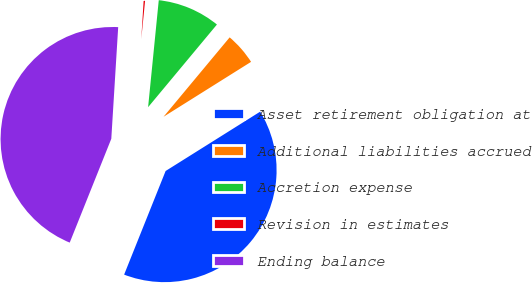Convert chart. <chart><loc_0><loc_0><loc_500><loc_500><pie_chart><fcel>Asset retirement obligation at<fcel>Additional liabilities accrued<fcel>Accretion expense<fcel>Revision in estimates<fcel>Ending balance<nl><fcel>39.98%<fcel>5.03%<fcel>9.47%<fcel>0.6%<fcel>44.92%<nl></chart> 